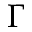<formula> <loc_0><loc_0><loc_500><loc_500>\Gamma</formula> 